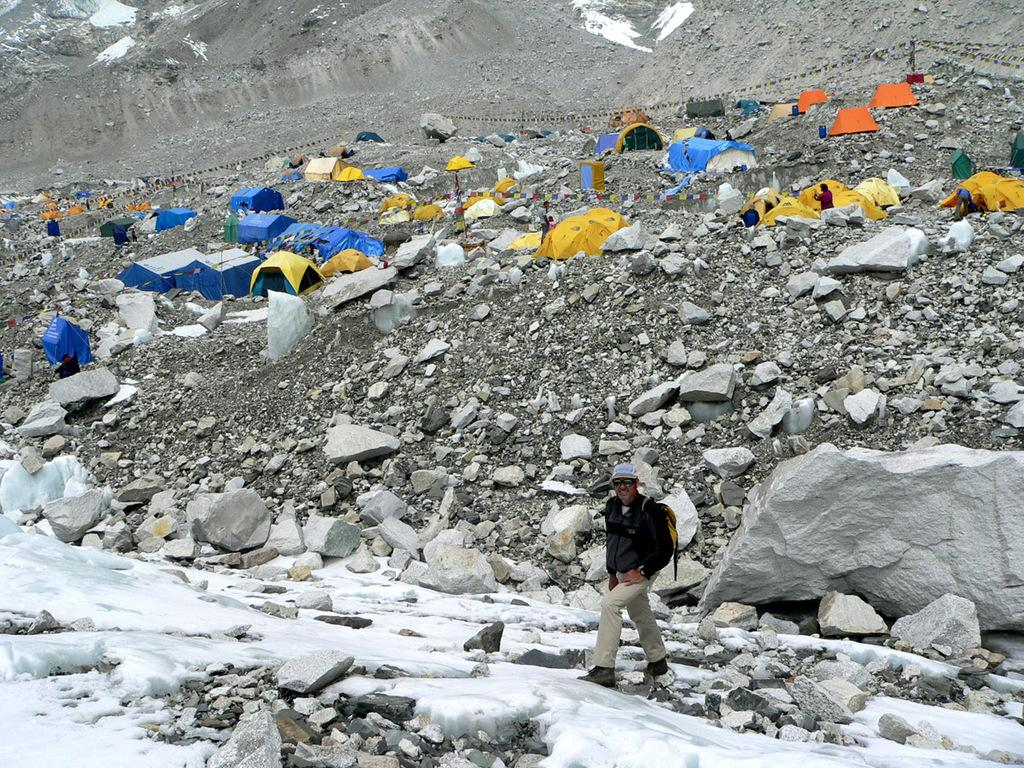What is the main subject of the image? The main subject of the image is a man. What is the man doing in the image? The man is walking in the image. What accessories is the man wearing in the image? The man is wearing a cap on his head and sunglasses on his face. What is the man carrying in the image? The man is carrying a backpack on his back. What additional elements can be seen in the image? There are tents, rocks, and people standing in the image. What type of pollution can be seen in the image? There is no pollution visible in the image. What type of eggnog is the man drinking in the image? There is no eggnog present in the image. 